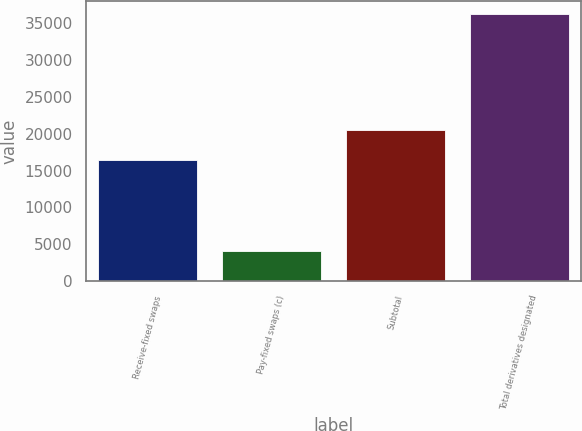<chart> <loc_0><loc_0><loc_500><loc_500><bar_chart><fcel>Receive-fixed swaps<fcel>Pay-fixed swaps (c)<fcel>Subtotal<fcel>Total derivatives designated<nl><fcel>16446<fcel>4076<fcel>20522<fcel>36197<nl></chart> 